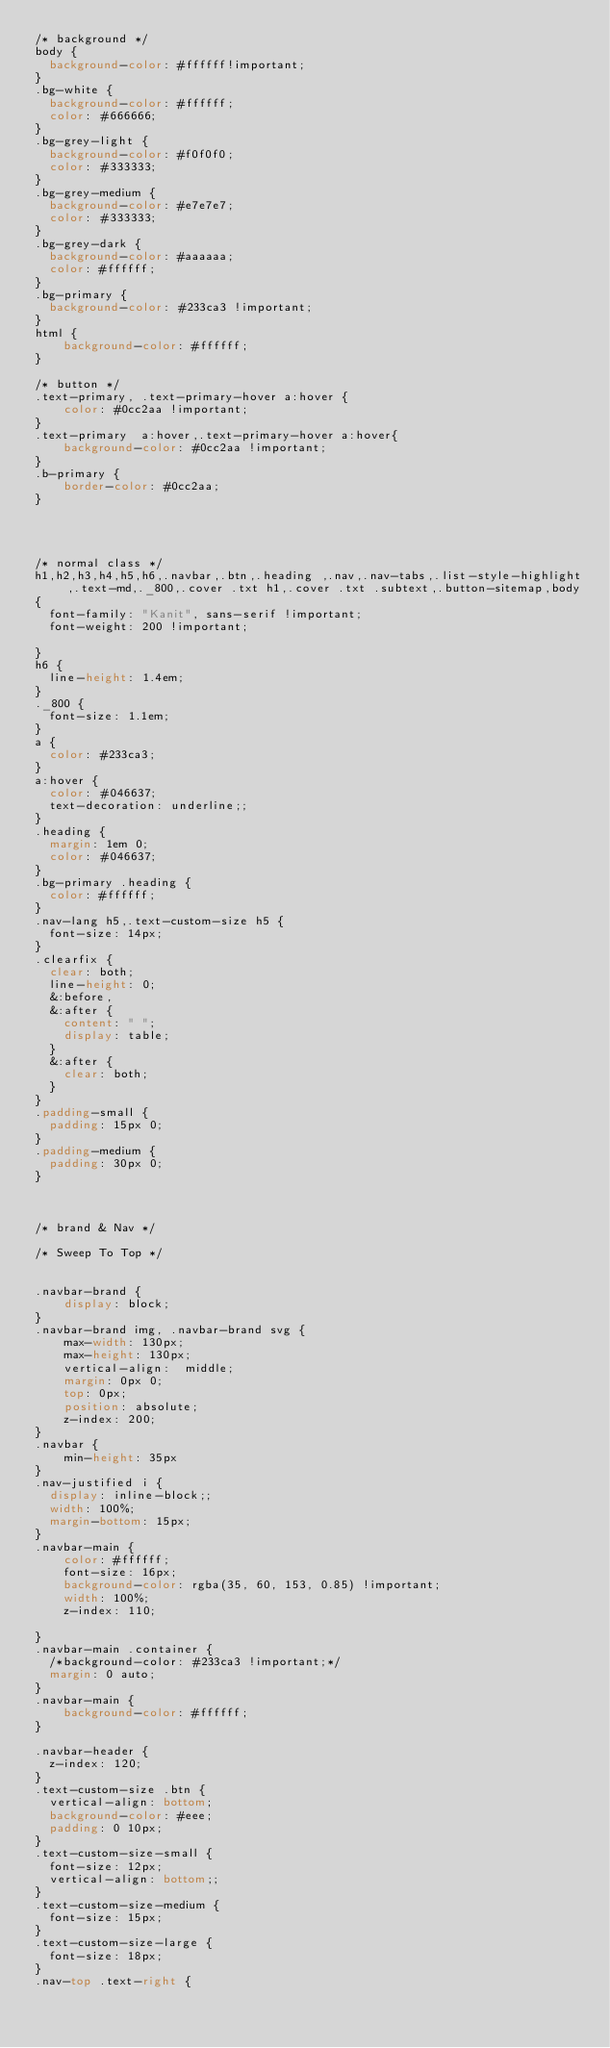Convert code to text. <code><loc_0><loc_0><loc_500><loc_500><_CSS_>/* background */
body {
  background-color: #ffffff!important;
}
.bg-white {
  background-color: #ffffff;
  color: #666666;
}
.bg-grey-light {
  background-color: #f0f0f0;
  color: #333333;
}
.bg-grey-medium {
  background-color: #e7e7e7;
  color: #333333;
}
.bg-grey-dark {
  background-color: #aaaaaa;
  color: #ffffff;
}
.bg-primary {
  background-color: #233ca3 !important;
}
html {
    background-color: #ffffff;
}

/* button */
.text-primary, .text-primary-hover a:hover {
    color: #0cc2aa !important;
}
.text-primary  a:hover,.text-primary-hover a:hover{
    background-color: #0cc2aa !important;
}
.b-primary {
    border-color: #0cc2aa;
}




/* normal class */
h1,h2,h3,h4,h5,h6,.navbar,.btn,.heading ,.nav,.nav-tabs,.list-style-highlight,.text-md,._800,.cover .txt h1,.cover .txt .subtext,.button-sitemap,body
{
	font-family: "Kanit", sans-serif !important;
	font-weight: 200 !important;

}
h6 {
  line-height: 1.4em;
}
._800 {
  font-size: 1.1em;
}
a {
  color: #233ca3;
}
a:hover {
  color: #046637;
  text-decoration: underline;;
}
.heading {
  margin: 1em 0;
  color: #046637;
}
.bg-primary .heading {
  color: #ffffff;
}
.nav-lang h5,.text-custom-size h5 {
  font-size: 14px;
}
.clearfix {
  clear: both;
  line-height: 0;
  &:before,
  &:after {
    content: " ";
    display: table;
  }
  &:after {
    clear: both;
  }
}
.padding-small {
  padding: 15px 0;
}
.padding-medium {
  padding: 30px 0;
}



/* brand & Nav */

/* Sweep To Top */


.navbar-brand {
    display: block;
}
.navbar-brand img, .navbar-brand svg {
    max-width: 130px;
    max-height: 130px;
    vertical-align:  middle;
    margin: 0px 0;
    top: 0px;
    position: absolute;
    z-index: 200;
}
.navbar {
    min-height: 35px
}
.nav-justified i {
  display: inline-block;;
  width: 100%;
  margin-bottom: 15px;
}
.navbar-main {
    color: #ffffff;
    font-size: 16px;
    background-color: rgba(35, 60, 153, 0.85) !important;
    width: 100%;
    z-index: 110;

}
.navbar-main .container {
  /*background-color: #233ca3 !important;*/
  margin: 0 auto;
}
.navbar-main {
    background-color: #ffffff;
}

.navbar-header {
  z-index: 120;
}
.text-custom-size .btn {
	vertical-align: bottom;
	background-color: #eee;
	padding: 0 10px;
}
.text-custom-size-small {
	font-size: 12px;
	vertical-align: bottom;;
}
.text-custom-size-medium {
	font-size: 15px;
}
.text-custom-size-large {
	font-size: 18px;
}
.nav-top .text-right {</code> 